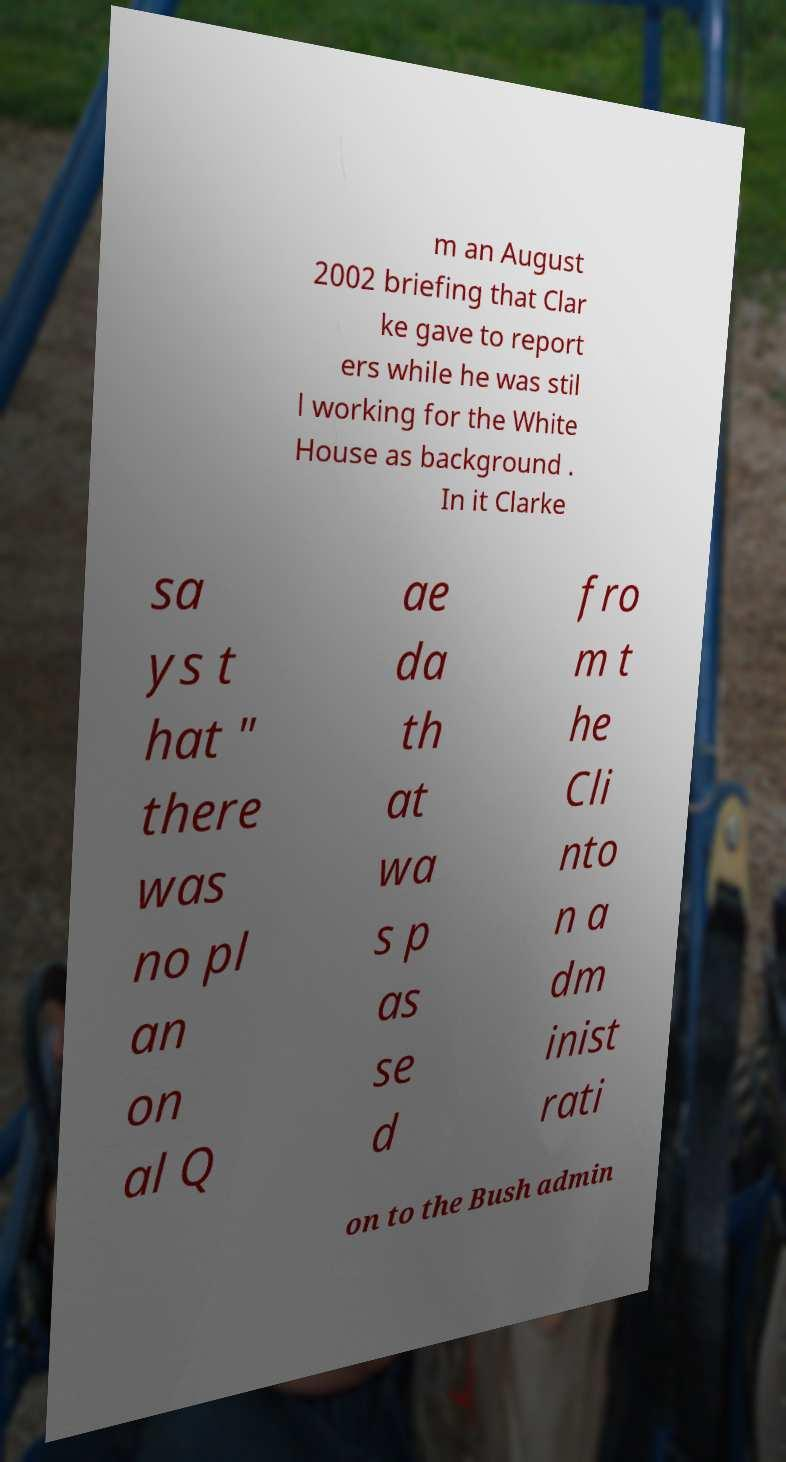Please read and relay the text visible in this image. What does it say? m an August 2002 briefing that Clar ke gave to report ers while he was stil l working for the White House as background . In it Clarke sa ys t hat " there was no pl an on al Q ae da th at wa s p as se d fro m t he Cli nto n a dm inist rati on to the Bush admin 